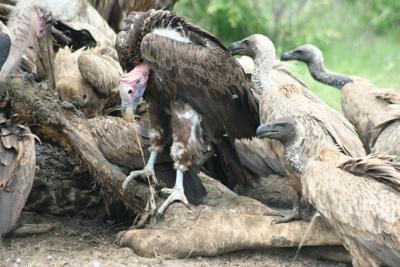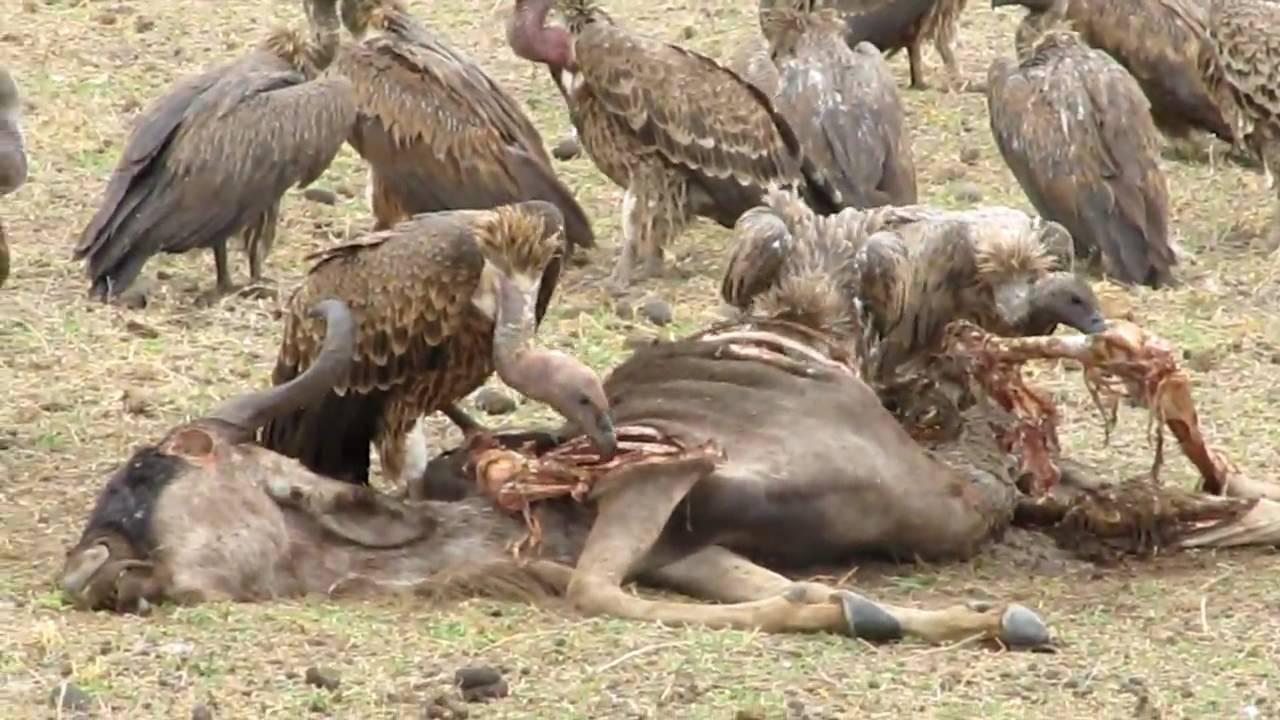The first image is the image on the left, the second image is the image on the right. Considering the images on both sides, is "In one of the images, the carrion birds are NOT eating anything at the moment." valid? Answer yes or no. No. 